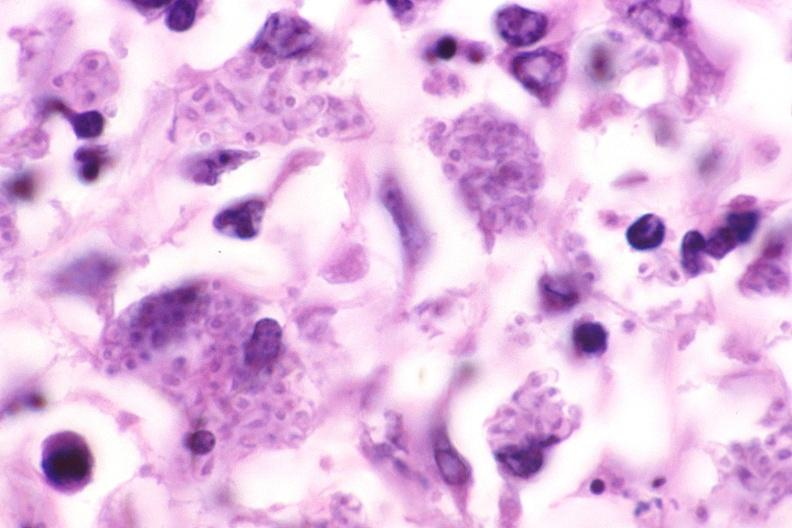does this image show lung, histoplasma pneumonia?
Answer the question using a single word or phrase. Yes 